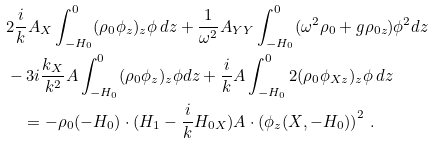<formula> <loc_0><loc_0><loc_500><loc_500>& 2 \frac { i } { k } A _ { X } \int ^ { 0 } _ { - H _ { 0 } } ( \rho _ { 0 } \phi _ { z } ) _ { z } \phi \, d z + \frac { 1 } { \omega ^ { 2 } } A _ { Y Y } \int ^ { 0 } _ { - H _ { 0 } } ( \omega ^ { 2 } \rho _ { 0 } + g \rho _ { 0 z } ) \phi ^ { 2 } d z \\ & - 3 i \frac { k _ { X } } { k ^ { 2 } } A \int ^ { 0 } _ { - H _ { 0 } } ( \rho _ { 0 } \phi _ { z } ) _ { z } \phi d z + \frac { i } { k } A \int ^ { 0 } _ { - H _ { 0 } } 2 ( \rho _ { 0 } \phi _ { X z } ) _ { z } \phi \, d z \\ & \quad = - \rho _ { 0 } ( - H _ { 0 } ) \cdot ( H _ { 1 } - \frac { i } { k } H _ { 0 X } ) A \cdot \left ( \phi _ { z } ( X , - H _ { 0 } ) \right ) ^ { 2 } \, .</formula> 